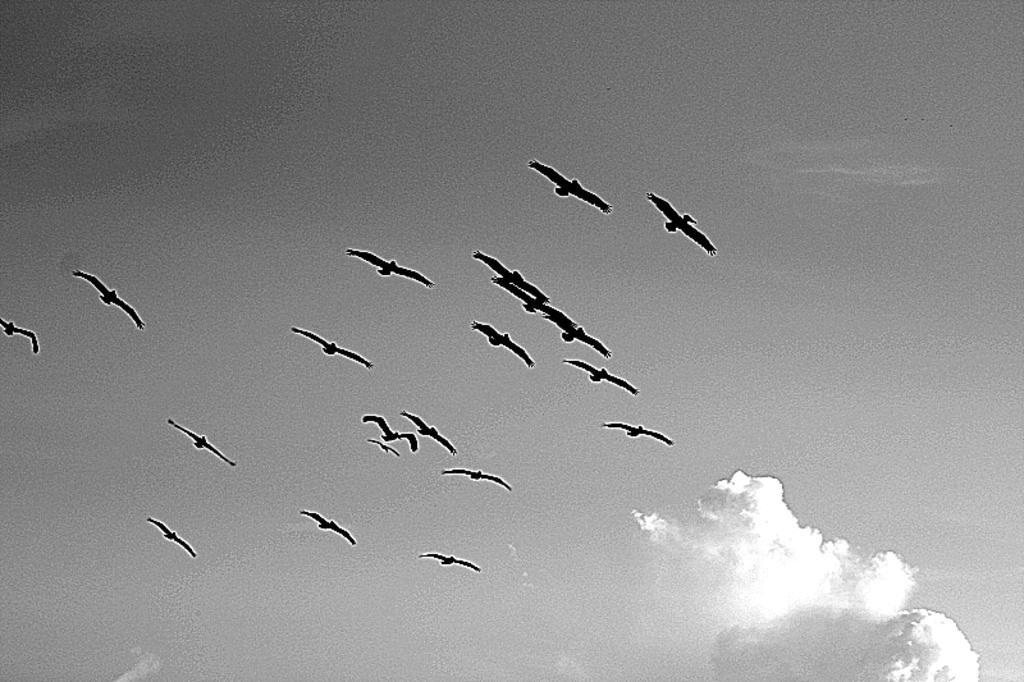In one or two sentences, can you explain what this image depicts? Here in this picture birds flying in the sky and we can see clouds in the sky over there. 